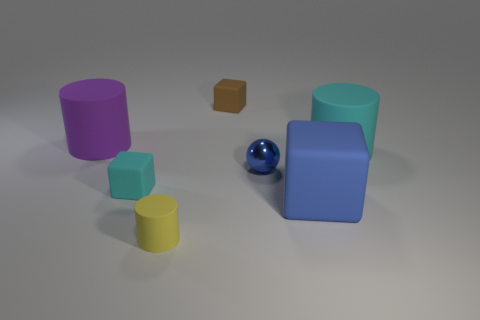Add 2 big matte blocks. How many objects exist? 9 Subtract all spheres. How many objects are left? 6 Subtract 1 purple cylinders. How many objects are left? 6 Subtract all cyan things. Subtract all large rubber cylinders. How many objects are left? 3 Add 1 large blue rubber objects. How many large blue rubber objects are left? 2 Add 7 large purple spheres. How many large purple spheres exist? 7 